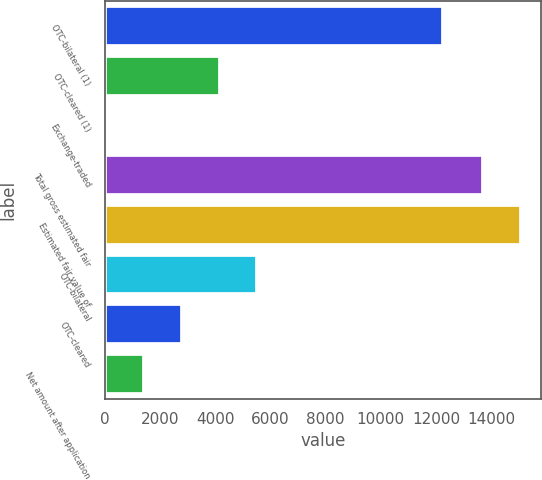Convert chart. <chart><loc_0><loc_0><loc_500><loc_500><bar_chart><fcel>OTC-bilateral (1)<fcel>OTC-cleared (1)<fcel>Exchange-traded<fcel>Total gross estimated fair<fcel>Estimated fair value of<fcel>OTC-bilateral<fcel>OTC-cleared<fcel>Net amount after application<nl><fcel>12256<fcel>4161.8<fcel>71<fcel>13707<fcel>15070.6<fcel>5525.4<fcel>2798.2<fcel>1434.6<nl></chart> 